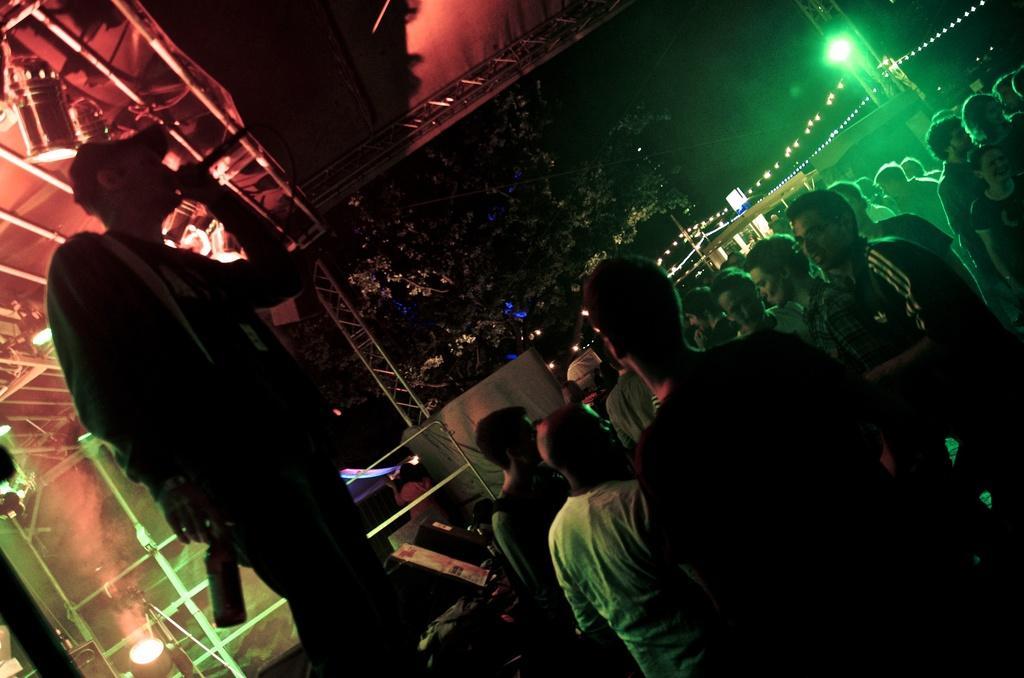Please provide a concise description of this image. It is a music concert, there is a person standing on the stage and he is holding a bottle in his hand and on the other hand he is holding a mic , there are many lights above the person and there is a huge crowd in front of the stage and behind the crowd there is a green light and on the left side there is a tree. 